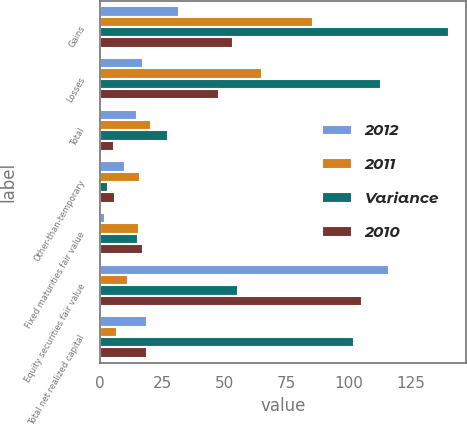Convert chart. <chart><loc_0><loc_0><loc_500><loc_500><stacked_bar_chart><ecel><fcel>Gains<fcel>Losses<fcel>Total<fcel>Other-than-temporary<fcel>Fixed maturities fair value<fcel>Equity securities fair value<fcel>Total net realized capital<nl><fcel>2012<fcel>31.9<fcel>17.2<fcel>14.7<fcel>10<fcel>1.9<fcel>116.2<fcel>18.9<nl><fcel>2011<fcel>85.5<fcel>65.1<fcel>20.4<fcel>16.2<fcel>15.5<fcel>11.1<fcel>6.9<nl><fcel>Variance<fcel>140.2<fcel>112.8<fcel>27.5<fcel>3<fcel>15.1<fcel>55.3<fcel>101.9<nl><fcel>2010<fcel>53.6<fcel>47.9<fcel>5.7<fcel>6.2<fcel>17.4<fcel>105.1<fcel>18.9<nl></chart> 